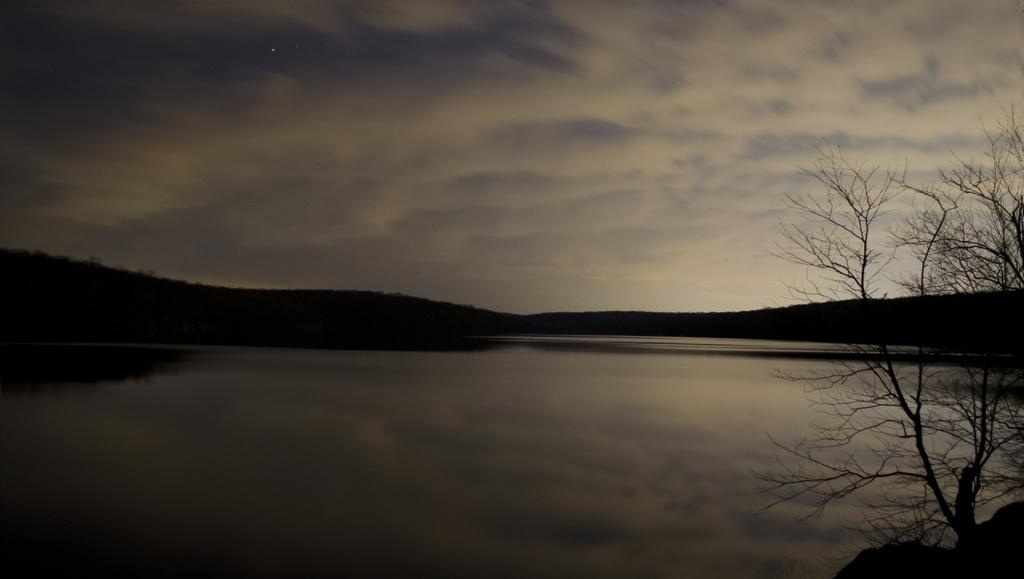What is the primary element in the image? There is water in the image. What type of vegetation can be seen on the right side of the image? There is a bare tree on the right side of the image. How would you describe the overall lighting in the image? The background of the image is dark. What can be seen in the sky in the image? Clouds are visible in the sky. What type of coil is wrapped around the tree in the image? There is no coil present in the image; it only features a bare tree and water. 